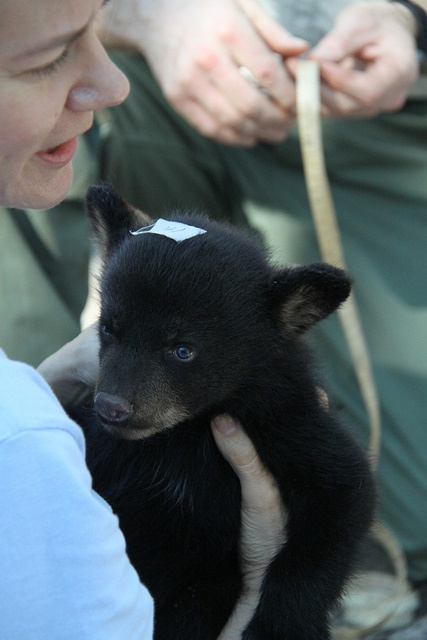Describe the objects in this image and their specific colors. I can see bear in gray, black, purple, and darkblue tones, people in gray, lightblue, and darkgray tones, and people in gray, lightgray, darkgray, and tan tones in this image. 